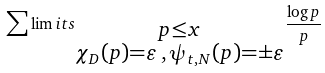Convert formula to latex. <formula><loc_0><loc_0><loc_500><loc_500>\sum \lim i t s _ { \substack { p \leq x \\ \chi _ { D } ( p ) = \varepsilon \, , \, \psi _ { t , N } ( p ) = \pm \varepsilon } } \frac { \log p } { p }</formula> 